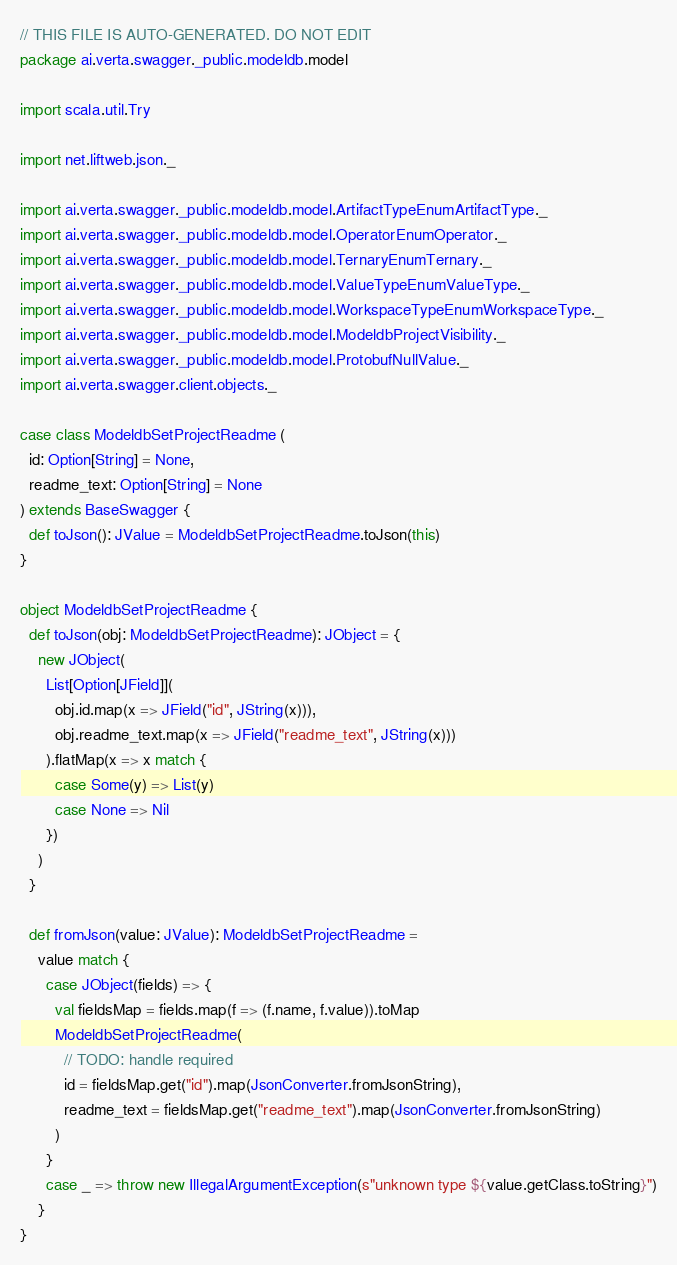<code> <loc_0><loc_0><loc_500><loc_500><_Scala_>// THIS FILE IS AUTO-GENERATED. DO NOT EDIT
package ai.verta.swagger._public.modeldb.model

import scala.util.Try

import net.liftweb.json._

import ai.verta.swagger._public.modeldb.model.ArtifactTypeEnumArtifactType._
import ai.verta.swagger._public.modeldb.model.OperatorEnumOperator._
import ai.verta.swagger._public.modeldb.model.TernaryEnumTernary._
import ai.verta.swagger._public.modeldb.model.ValueTypeEnumValueType._
import ai.verta.swagger._public.modeldb.model.WorkspaceTypeEnumWorkspaceType._
import ai.verta.swagger._public.modeldb.model.ModeldbProjectVisibility._
import ai.verta.swagger._public.modeldb.model.ProtobufNullValue._
import ai.verta.swagger.client.objects._

case class ModeldbSetProjectReadme (
  id: Option[String] = None,
  readme_text: Option[String] = None
) extends BaseSwagger {
  def toJson(): JValue = ModeldbSetProjectReadme.toJson(this)
}

object ModeldbSetProjectReadme {
  def toJson(obj: ModeldbSetProjectReadme): JObject = {
    new JObject(
      List[Option[JField]](
        obj.id.map(x => JField("id", JString(x))),
        obj.readme_text.map(x => JField("readme_text", JString(x)))
      ).flatMap(x => x match {
        case Some(y) => List(y)
        case None => Nil
      })
    )
  }

  def fromJson(value: JValue): ModeldbSetProjectReadme =
    value match {
      case JObject(fields) => {
        val fieldsMap = fields.map(f => (f.name, f.value)).toMap
        ModeldbSetProjectReadme(
          // TODO: handle required
          id = fieldsMap.get("id").map(JsonConverter.fromJsonString),
          readme_text = fieldsMap.get("readme_text").map(JsonConverter.fromJsonString)
        )
      }
      case _ => throw new IllegalArgumentException(s"unknown type ${value.getClass.toString}")
    }
}
</code> 